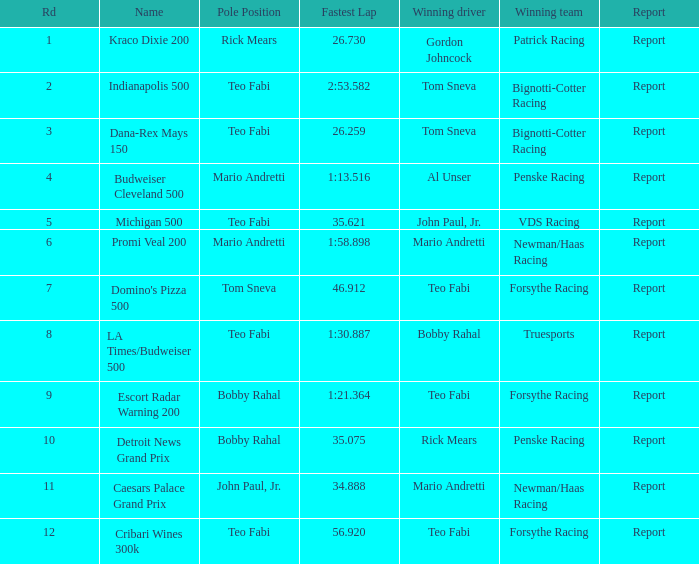What was the most rapid lap time in the escort radar warning 200? 1:21.364. 